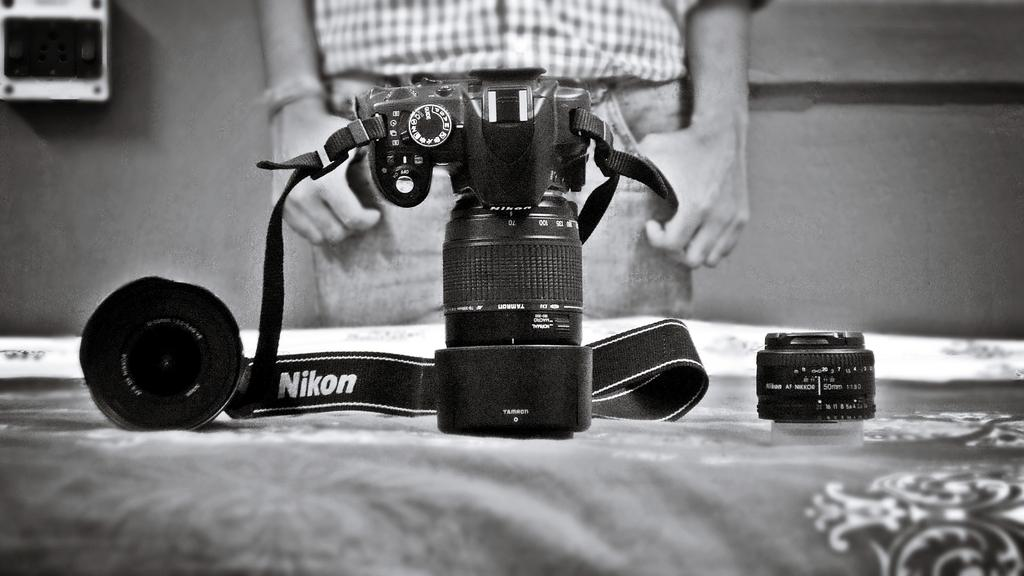What is the main subject in the foreground of the image? There is a camera in the foreground of the image. What is the position of the camera's lid in relation to the camera? The camera's lid is beside the camera. Can you describe the background of the image? There is a person and an object in the background of the image. What type of offer is being made in the lunchroom in the image? There is no lunchroom or offer present in the image; it features a camera and its lid in the foreground, with a person and an object in the background. 